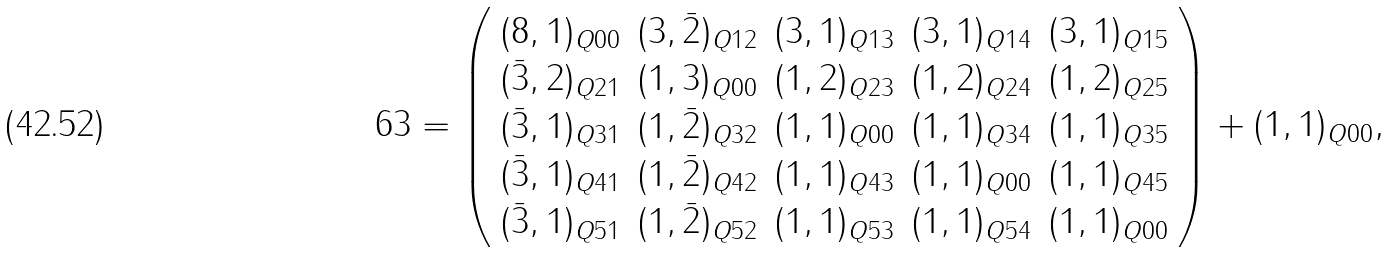Convert formula to latex. <formula><loc_0><loc_0><loc_500><loc_500>6 3 = \left ( \begin{array} { c c c c c } ( 8 , 1 ) _ { Q 0 0 } & ( 3 , \bar { 2 } ) _ { Q 1 2 } & ( 3 , 1 ) _ { Q 1 3 } & ( 3 , 1 ) _ { Q 1 4 } & ( 3 , 1 ) _ { Q 1 5 } \\ ( \bar { 3 } , 2 ) _ { Q 2 1 } & ( 1 , 3 ) _ { Q 0 0 } & ( 1 , 2 ) _ { Q 2 3 } & ( 1 , 2 ) _ { Q 2 4 } & ( 1 , 2 ) _ { Q 2 5 } \\ ( \bar { 3 } , 1 ) _ { Q 3 1 } & ( 1 , \bar { 2 } ) _ { Q 3 2 } & ( 1 , 1 ) _ { Q 0 0 } & ( 1 , 1 ) _ { Q 3 4 } & ( 1 , 1 ) _ { Q 3 5 } \\ ( \bar { 3 } , 1 ) _ { Q 4 1 } & ( 1 , \bar { 2 } ) _ { Q 4 2 } & ( 1 , 1 ) _ { Q 4 3 } & ( 1 , 1 ) _ { Q 0 0 } & ( 1 , 1 ) _ { Q 4 5 } \\ ( \bar { 3 } , 1 ) _ { Q 5 1 } & ( 1 , \bar { 2 } ) _ { Q 5 2 } & ( 1 , 1 ) _ { Q 5 3 } & ( 1 , 1 ) _ { Q 5 4 } & ( 1 , 1 ) _ { Q 0 0 } \end{array} \right ) + ( 1 , 1 ) _ { Q 0 0 } , \,</formula> 